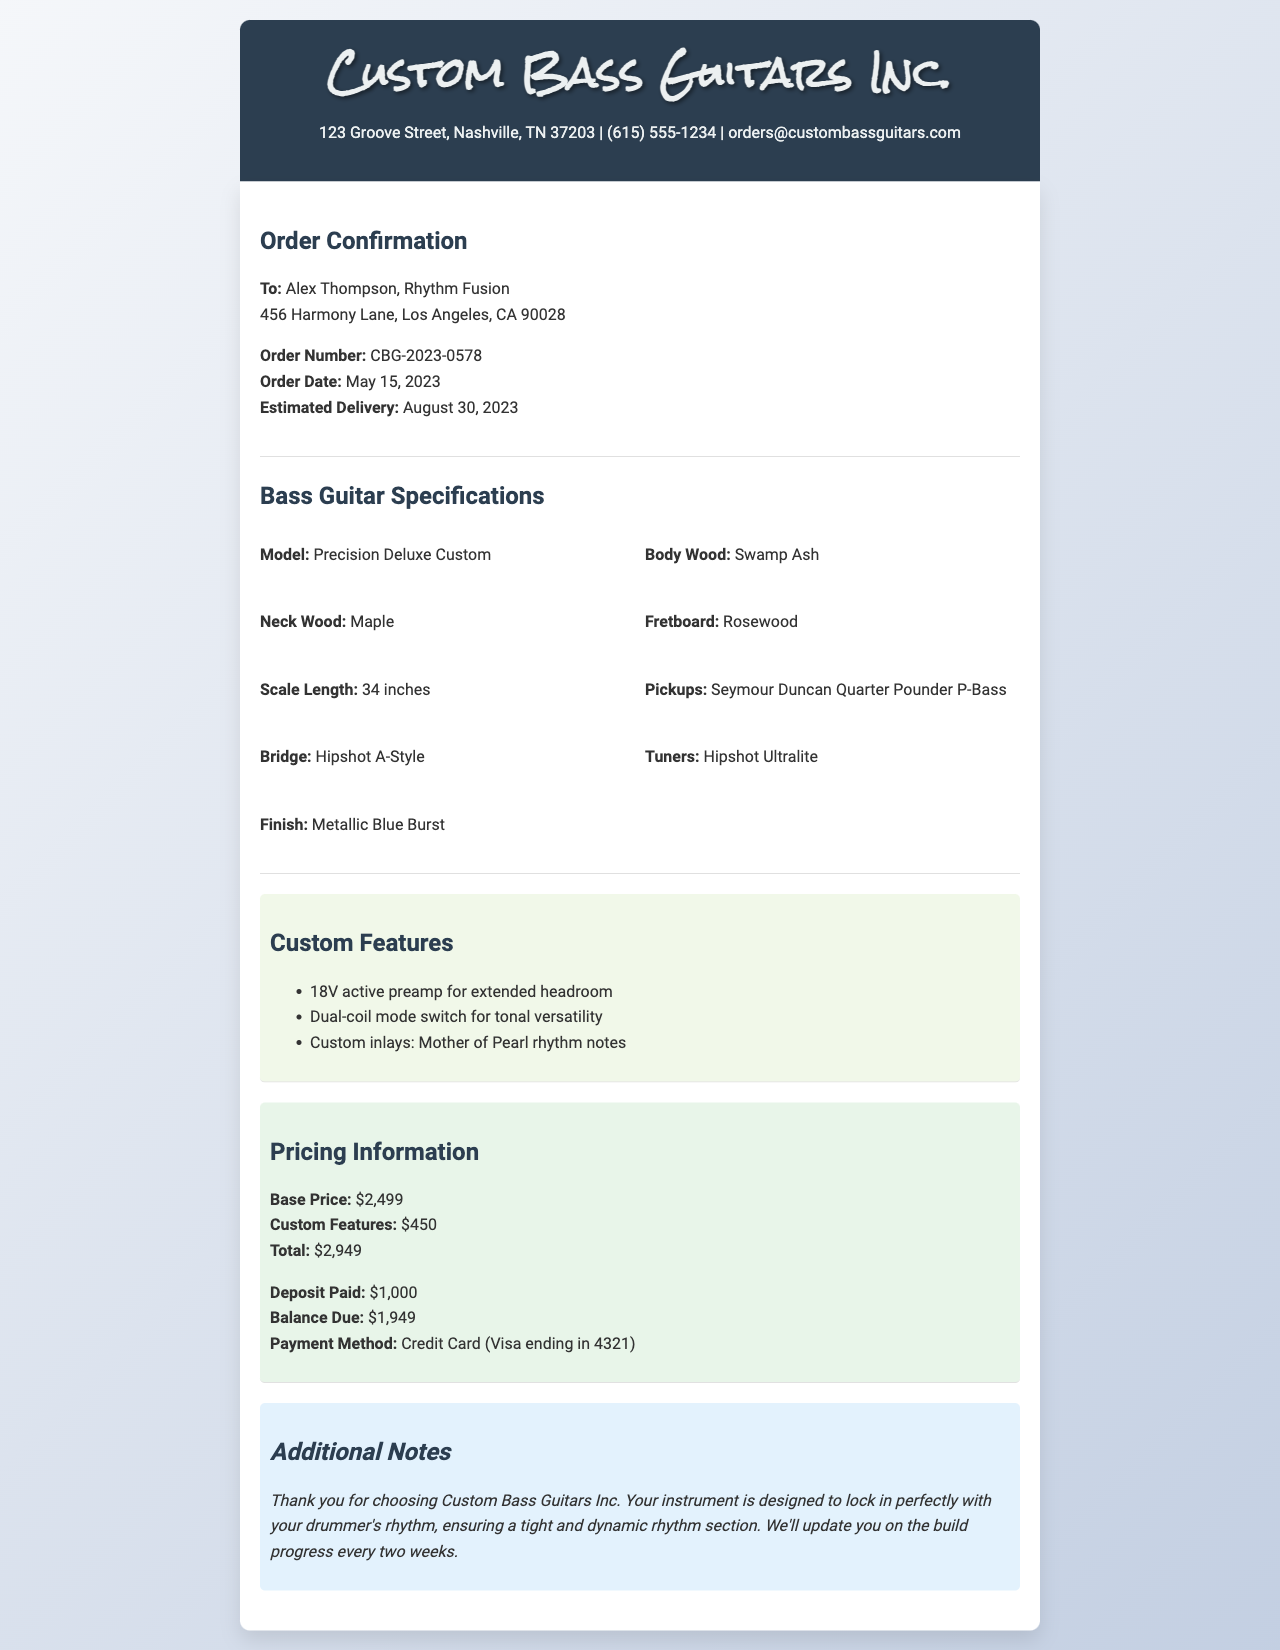What is the recipient's name? The recipient's name is stated in the "To:" section of the document.
Answer: Alex Thompson What is the order number? The order number is mentioned prominently in the order details section.
Answer: CBG-2023-0578 What is the estimated delivery date? The estimated delivery date is provided in the order details section.
Answer: August 30, 2023 What type of pickups are used in the bass guitar? The pickups type is specified under "Bass Guitar Specifications."
Answer: Seymour Duncan Quarter Pounder P-Bass What is the total price of the custom bass guitar? The total price is calculated from the pricing information provided near the end of the document.
Answer: $2,949 How much deposit was paid? The amount of deposit is indicated in the "Pricing Information" section.
Answer: $1,000 What finish color is chosen for the guitar? The finish color is listed in the specifications section of the document.
Answer: Metallic Blue Burst What custom feature provides tonal versatility? The custom features are outlined, and one specifically mentions tonal versatility.
Answer: Dual-coil mode switch What is the method of payment? The payment method is part of the pricing information at the end of the document.
Answer: Credit Card (Visa ending in 4321) 